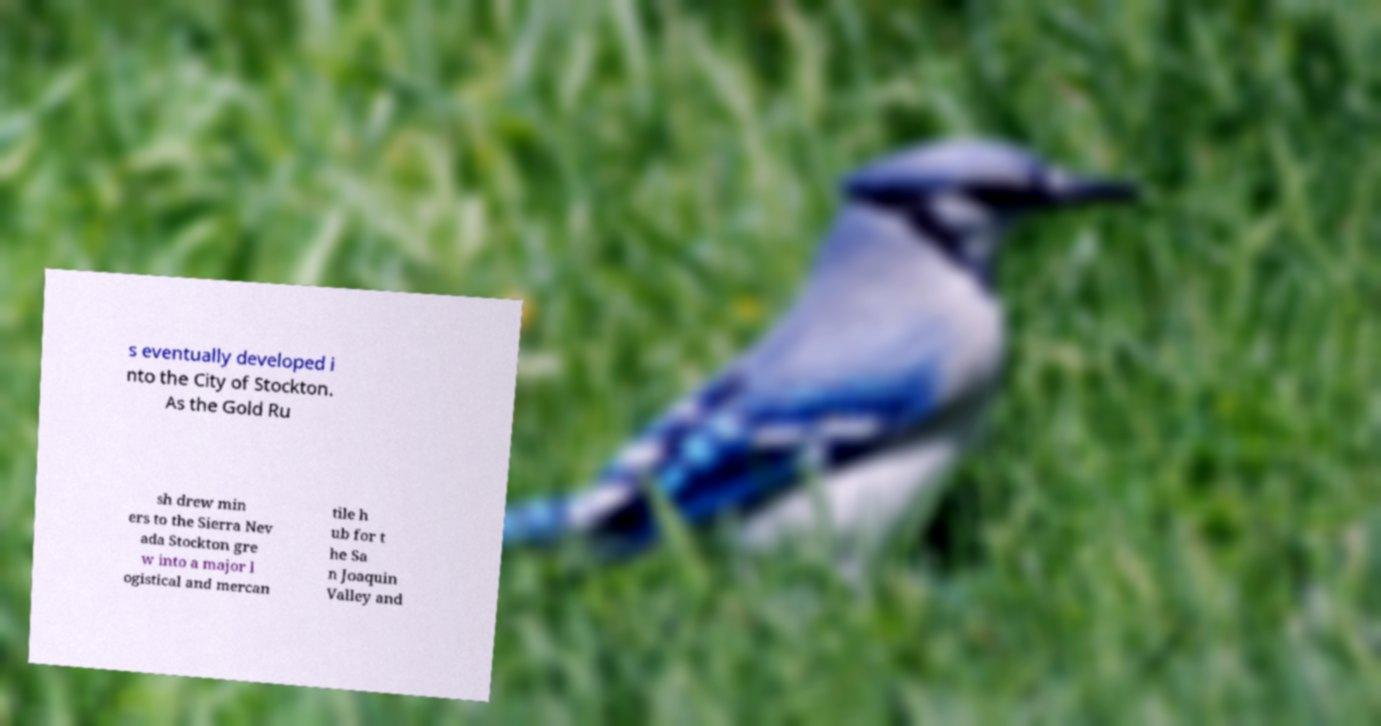Please read and relay the text visible in this image. What does it say? s eventually developed i nto the City of Stockton. As the Gold Ru sh drew min ers to the Sierra Nev ada Stockton gre w into a major l ogistical and mercan tile h ub for t he Sa n Joaquin Valley and 